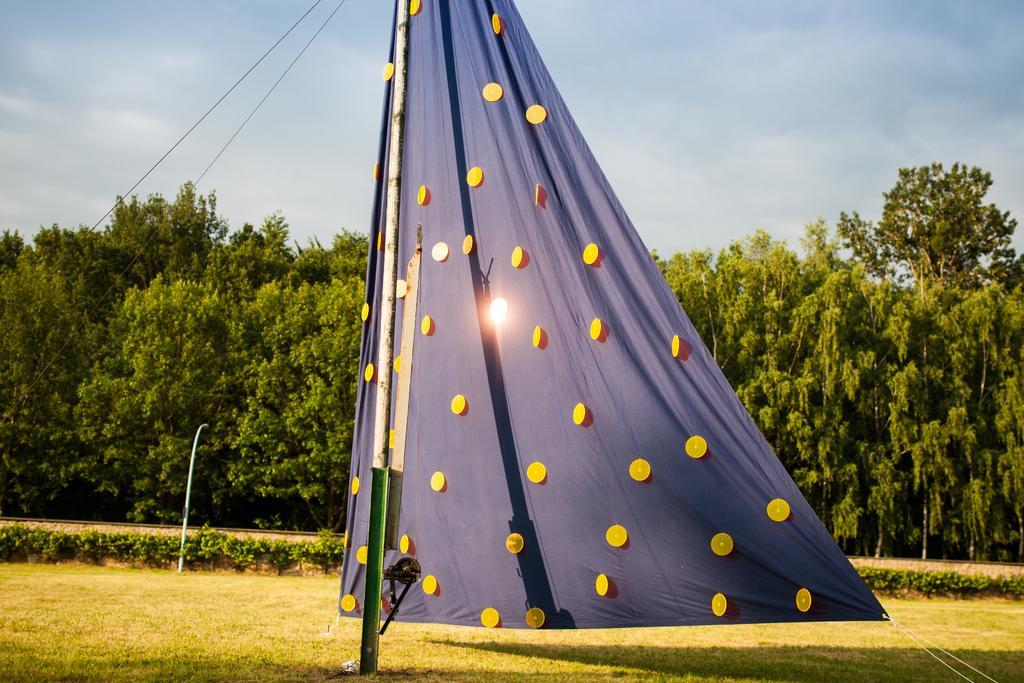How would you summarize this image in a sentence or two? In this picture there is a tent in the center of the image, there is grassland at the bottom side of the image and there are trees in the background area of the image. 